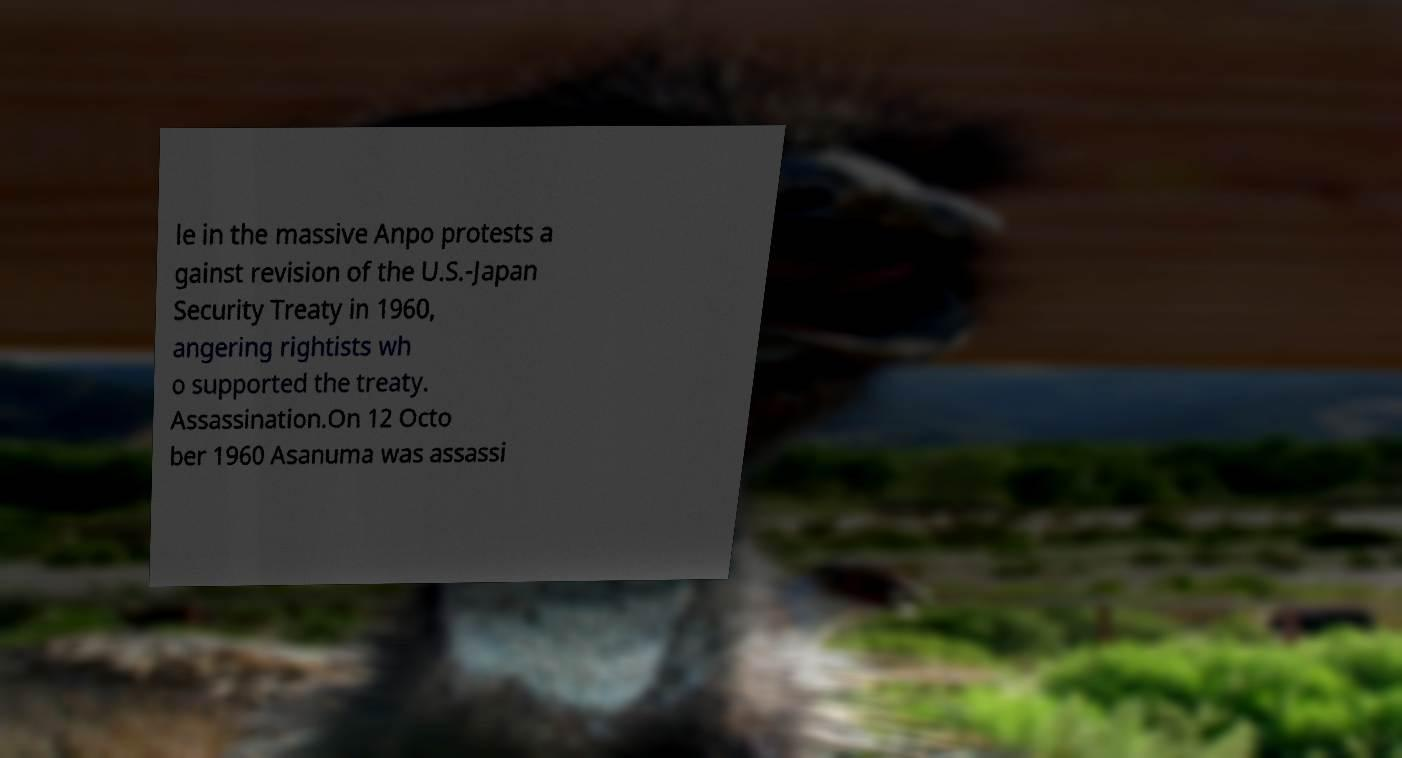Please read and relay the text visible in this image. What does it say? le in the massive Anpo protests a gainst revision of the U.S.-Japan Security Treaty in 1960, angering rightists wh o supported the treaty. Assassination.On 12 Octo ber 1960 Asanuma was assassi 